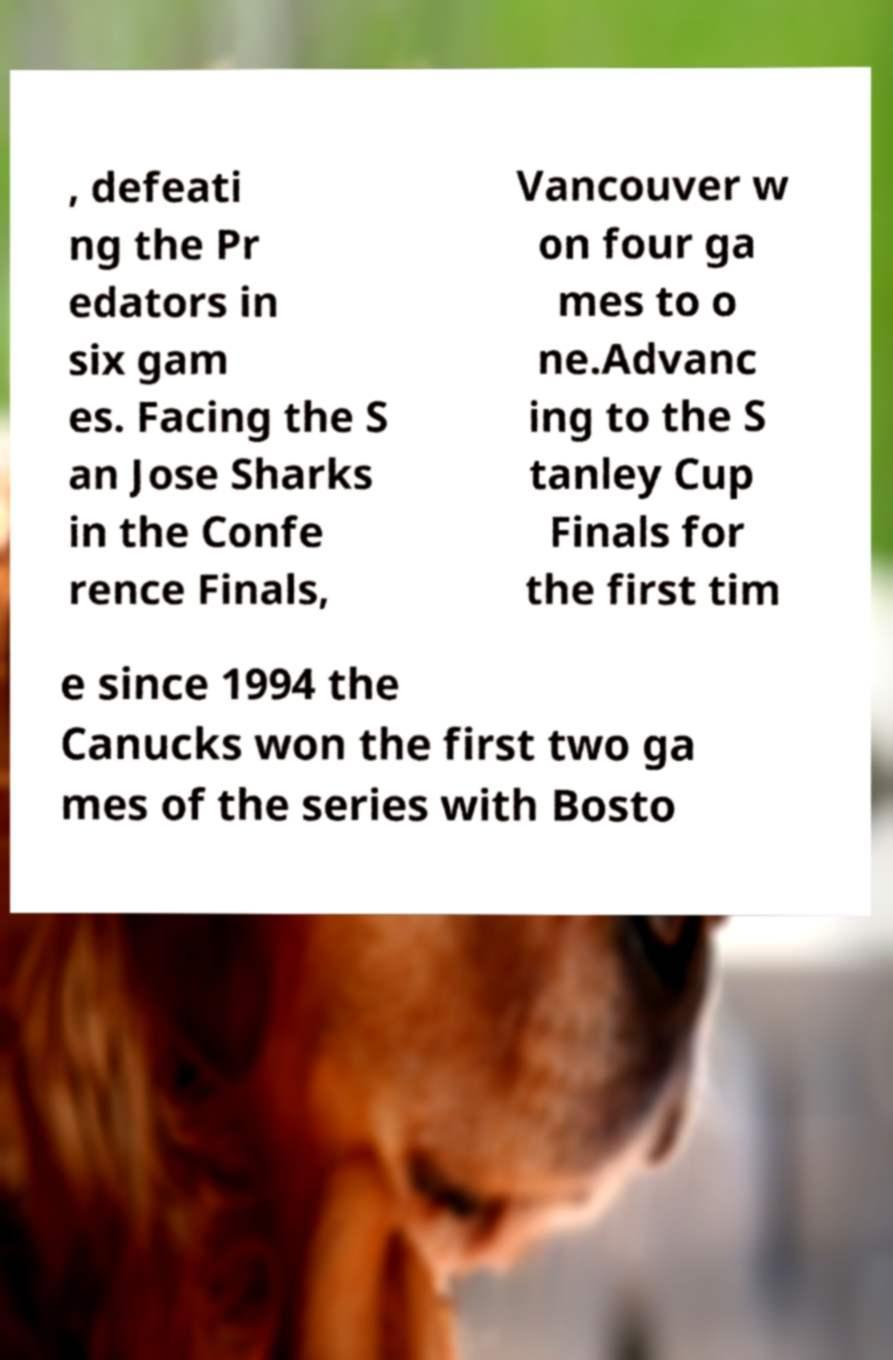I need the written content from this picture converted into text. Can you do that? , defeati ng the Pr edators in six gam es. Facing the S an Jose Sharks in the Confe rence Finals, Vancouver w on four ga mes to o ne.Advanc ing to the S tanley Cup Finals for the first tim e since 1994 the Canucks won the first two ga mes of the series with Bosto 